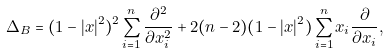<formula> <loc_0><loc_0><loc_500><loc_500>\Delta _ { B } = ( 1 - | x | ^ { 2 } ) ^ { 2 } \sum _ { i = 1 } ^ { n } \frac { \partial ^ { 2 } } { \partial x _ { i } ^ { 2 } } + 2 ( n - 2 ) ( 1 - | x | ^ { 2 } ) \sum _ { i = 1 } ^ { n } x _ { i } \frac { \partial } { \partial x _ { i } } \/ ,</formula> 